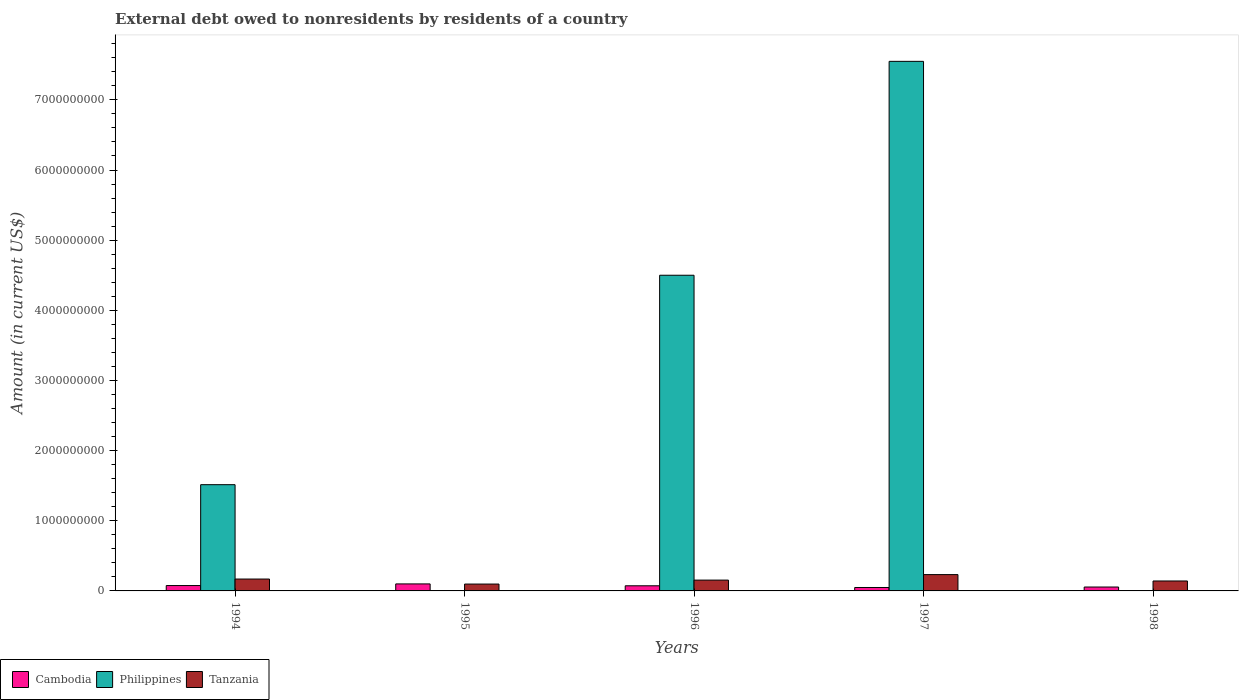How many groups of bars are there?
Provide a succinct answer. 5. Are the number of bars per tick equal to the number of legend labels?
Your answer should be very brief. No. How many bars are there on the 4th tick from the left?
Make the answer very short. 3. How many bars are there on the 1st tick from the right?
Give a very brief answer. 2. What is the external debt owed by residents in Tanzania in 1994?
Offer a very short reply. 1.69e+08. Across all years, what is the maximum external debt owed by residents in Philippines?
Your answer should be very brief. 7.55e+09. Across all years, what is the minimum external debt owed by residents in Cambodia?
Your response must be concise. 4.88e+07. In which year was the external debt owed by residents in Philippines maximum?
Provide a short and direct response. 1997. What is the total external debt owed by residents in Tanzania in the graph?
Ensure brevity in your answer.  7.96e+08. What is the difference between the external debt owed by residents in Tanzania in 1995 and that in 1998?
Offer a terse response. -4.38e+07. What is the difference between the external debt owed by residents in Tanzania in 1996 and the external debt owed by residents in Cambodia in 1995?
Your answer should be very brief. 5.44e+07. What is the average external debt owed by residents in Tanzania per year?
Your response must be concise. 1.59e+08. In the year 1997, what is the difference between the external debt owed by residents in Cambodia and external debt owed by residents in Philippines?
Give a very brief answer. -7.50e+09. What is the ratio of the external debt owed by residents in Cambodia in 1995 to that in 1996?
Offer a terse response. 1.37. Is the external debt owed by residents in Cambodia in 1997 less than that in 1998?
Your response must be concise. Yes. What is the difference between the highest and the second highest external debt owed by residents in Cambodia?
Your answer should be compact. 2.35e+07. What is the difference between the highest and the lowest external debt owed by residents in Philippines?
Provide a succinct answer. 7.55e+09. Is it the case that in every year, the sum of the external debt owed by residents in Cambodia and external debt owed by residents in Philippines is greater than the external debt owed by residents in Tanzania?
Your answer should be very brief. No. What is the difference between two consecutive major ticks on the Y-axis?
Make the answer very short. 1.00e+09. Does the graph contain grids?
Your answer should be very brief. No. Where does the legend appear in the graph?
Offer a terse response. Bottom left. How are the legend labels stacked?
Ensure brevity in your answer.  Horizontal. What is the title of the graph?
Offer a terse response. External debt owed to nonresidents by residents of a country. Does "China" appear as one of the legend labels in the graph?
Your answer should be compact. No. What is the label or title of the X-axis?
Provide a succinct answer. Years. What is the label or title of the Y-axis?
Make the answer very short. Amount (in current US$). What is the Amount (in current US$) in Cambodia in 1994?
Provide a succinct answer. 7.64e+07. What is the Amount (in current US$) of Philippines in 1994?
Offer a terse response. 1.51e+09. What is the Amount (in current US$) of Tanzania in 1994?
Offer a very short reply. 1.69e+08. What is the Amount (in current US$) in Cambodia in 1995?
Offer a very short reply. 1.00e+08. What is the Amount (in current US$) in Tanzania in 1995?
Give a very brief answer. 9.79e+07. What is the Amount (in current US$) in Cambodia in 1996?
Provide a succinct answer. 7.31e+07. What is the Amount (in current US$) of Philippines in 1996?
Your response must be concise. 4.50e+09. What is the Amount (in current US$) in Tanzania in 1996?
Your response must be concise. 1.54e+08. What is the Amount (in current US$) of Cambodia in 1997?
Your response must be concise. 4.88e+07. What is the Amount (in current US$) in Philippines in 1997?
Ensure brevity in your answer.  7.55e+09. What is the Amount (in current US$) of Tanzania in 1997?
Provide a succinct answer. 2.33e+08. What is the Amount (in current US$) in Cambodia in 1998?
Offer a terse response. 5.55e+07. What is the Amount (in current US$) of Tanzania in 1998?
Ensure brevity in your answer.  1.42e+08. Across all years, what is the maximum Amount (in current US$) of Cambodia?
Your answer should be compact. 1.00e+08. Across all years, what is the maximum Amount (in current US$) in Philippines?
Make the answer very short. 7.55e+09. Across all years, what is the maximum Amount (in current US$) of Tanzania?
Offer a very short reply. 2.33e+08. Across all years, what is the minimum Amount (in current US$) in Cambodia?
Give a very brief answer. 4.88e+07. Across all years, what is the minimum Amount (in current US$) in Philippines?
Provide a short and direct response. 0. Across all years, what is the minimum Amount (in current US$) of Tanzania?
Ensure brevity in your answer.  9.79e+07. What is the total Amount (in current US$) in Cambodia in the graph?
Provide a short and direct response. 3.54e+08. What is the total Amount (in current US$) in Philippines in the graph?
Your answer should be compact. 1.36e+1. What is the total Amount (in current US$) of Tanzania in the graph?
Keep it short and to the point. 7.96e+08. What is the difference between the Amount (in current US$) in Cambodia in 1994 and that in 1995?
Your answer should be very brief. -2.35e+07. What is the difference between the Amount (in current US$) in Tanzania in 1994 and that in 1995?
Your response must be concise. 7.14e+07. What is the difference between the Amount (in current US$) of Cambodia in 1994 and that in 1996?
Keep it short and to the point. 3.33e+06. What is the difference between the Amount (in current US$) in Philippines in 1994 and that in 1996?
Your answer should be very brief. -2.99e+09. What is the difference between the Amount (in current US$) of Tanzania in 1994 and that in 1996?
Keep it short and to the point. 1.50e+07. What is the difference between the Amount (in current US$) of Cambodia in 1994 and that in 1997?
Give a very brief answer. 2.76e+07. What is the difference between the Amount (in current US$) of Philippines in 1994 and that in 1997?
Provide a short and direct response. -6.03e+09. What is the difference between the Amount (in current US$) of Tanzania in 1994 and that in 1997?
Provide a short and direct response. -6.34e+07. What is the difference between the Amount (in current US$) of Cambodia in 1994 and that in 1998?
Provide a succinct answer. 2.09e+07. What is the difference between the Amount (in current US$) in Tanzania in 1994 and that in 1998?
Your response must be concise. 2.75e+07. What is the difference between the Amount (in current US$) of Cambodia in 1995 and that in 1996?
Make the answer very short. 2.69e+07. What is the difference between the Amount (in current US$) in Tanzania in 1995 and that in 1996?
Keep it short and to the point. -5.64e+07. What is the difference between the Amount (in current US$) in Cambodia in 1995 and that in 1997?
Provide a short and direct response. 5.12e+07. What is the difference between the Amount (in current US$) of Tanzania in 1995 and that in 1997?
Ensure brevity in your answer.  -1.35e+08. What is the difference between the Amount (in current US$) of Cambodia in 1995 and that in 1998?
Keep it short and to the point. 4.45e+07. What is the difference between the Amount (in current US$) of Tanzania in 1995 and that in 1998?
Your answer should be compact. -4.38e+07. What is the difference between the Amount (in current US$) in Cambodia in 1996 and that in 1997?
Make the answer very short. 2.43e+07. What is the difference between the Amount (in current US$) in Philippines in 1996 and that in 1997?
Make the answer very short. -3.05e+09. What is the difference between the Amount (in current US$) of Tanzania in 1996 and that in 1997?
Make the answer very short. -7.84e+07. What is the difference between the Amount (in current US$) in Cambodia in 1996 and that in 1998?
Give a very brief answer. 1.76e+07. What is the difference between the Amount (in current US$) of Tanzania in 1996 and that in 1998?
Your answer should be compact. 1.26e+07. What is the difference between the Amount (in current US$) in Cambodia in 1997 and that in 1998?
Keep it short and to the point. -6.68e+06. What is the difference between the Amount (in current US$) in Tanzania in 1997 and that in 1998?
Give a very brief answer. 9.10e+07. What is the difference between the Amount (in current US$) in Cambodia in 1994 and the Amount (in current US$) in Tanzania in 1995?
Offer a very short reply. -2.15e+07. What is the difference between the Amount (in current US$) of Philippines in 1994 and the Amount (in current US$) of Tanzania in 1995?
Offer a very short reply. 1.42e+09. What is the difference between the Amount (in current US$) of Cambodia in 1994 and the Amount (in current US$) of Philippines in 1996?
Give a very brief answer. -4.42e+09. What is the difference between the Amount (in current US$) in Cambodia in 1994 and the Amount (in current US$) in Tanzania in 1996?
Keep it short and to the point. -7.79e+07. What is the difference between the Amount (in current US$) in Philippines in 1994 and the Amount (in current US$) in Tanzania in 1996?
Provide a succinct answer. 1.36e+09. What is the difference between the Amount (in current US$) of Cambodia in 1994 and the Amount (in current US$) of Philippines in 1997?
Your answer should be compact. -7.47e+09. What is the difference between the Amount (in current US$) in Cambodia in 1994 and the Amount (in current US$) in Tanzania in 1997?
Your answer should be very brief. -1.56e+08. What is the difference between the Amount (in current US$) in Philippines in 1994 and the Amount (in current US$) in Tanzania in 1997?
Your response must be concise. 1.28e+09. What is the difference between the Amount (in current US$) of Cambodia in 1994 and the Amount (in current US$) of Tanzania in 1998?
Ensure brevity in your answer.  -6.53e+07. What is the difference between the Amount (in current US$) in Philippines in 1994 and the Amount (in current US$) in Tanzania in 1998?
Ensure brevity in your answer.  1.37e+09. What is the difference between the Amount (in current US$) in Cambodia in 1995 and the Amount (in current US$) in Philippines in 1996?
Your answer should be compact. -4.40e+09. What is the difference between the Amount (in current US$) of Cambodia in 1995 and the Amount (in current US$) of Tanzania in 1996?
Offer a very short reply. -5.44e+07. What is the difference between the Amount (in current US$) of Cambodia in 1995 and the Amount (in current US$) of Philippines in 1997?
Keep it short and to the point. -7.45e+09. What is the difference between the Amount (in current US$) in Cambodia in 1995 and the Amount (in current US$) in Tanzania in 1997?
Give a very brief answer. -1.33e+08. What is the difference between the Amount (in current US$) in Cambodia in 1995 and the Amount (in current US$) in Tanzania in 1998?
Ensure brevity in your answer.  -4.18e+07. What is the difference between the Amount (in current US$) of Cambodia in 1996 and the Amount (in current US$) of Philippines in 1997?
Your response must be concise. -7.48e+09. What is the difference between the Amount (in current US$) in Cambodia in 1996 and the Amount (in current US$) in Tanzania in 1997?
Your answer should be very brief. -1.60e+08. What is the difference between the Amount (in current US$) of Philippines in 1996 and the Amount (in current US$) of Tanzania in 1997?
Ensure brevity in your answer.  4.27e+09. What is the difference between the Amount (in current US$) of Cambodia in 1996 and the Amount (in current US$) of Tanzania in 1998?
Give a very brief answer. -6.87e+07. What is the difference between the Amount (in current US$) of Philippines in 1996 and the Amount (in current US$) of Tanzania in 1998?
Make the answer very short. 4.36e+09. What is the difference between the Amount (in current US$) of Cambodia in 1997 and the Amount (in current US$) of Tanzania in 1998?
Your answer should be compact. -9.30e+07. What is the difference between the Amount (in current US$) in Philippines in 1997 and the Amount (in current US$) in Tanzania in 1998?
Your answer should be very brief. 7.41e+09. What is the average Amount (in current US$) in Cambodia per year?
Keep it short and to the point. 7.08e+07. What is the average Amount (in current US$) in Philippines per year?
Make the answer very short. 2.71e+09. What is the average Amount (in current US$) of Tanzania per year?
Provide a short and direct response. 1.59e+08. In the year 1994, what is the difference between the Amount (in current US$) of Cambodia and Amount (in current US$) of Philippines?
Your answer should be compact. -1.44e+09. In the year 1994, what is the difference between the Amount (in current US$) of Cambodia and Amount (in current US$) of Tanzania?
Make the answer very short. -9.29e+07. In the year 1994, what is the difference between the Amount (in current US$) in Philippines and Amount (in current US$) in Tanzania?
Your answer should be compact. 1.35e+09. In the year 1995, what is the difference between the Amount (in current US$) in Cambodia and Amount (in current US$) in Tanzania?
Provide a short and direct response. 2.01e+06. In the year 1996, what is the difference between the Amount (in current US$) in Cambodia and Amount (in current US$) in Philippines?
Offer a terse response. -4.43e+09. In the year 1996, what is the difference between the Amount (in current US$) of Cambodia and Amount (in current US$) of Tanzania?
Your answer should be very brief. -8.12e+07. In the year 1996, what is the difference between the Amount (in current US$) in Philippines and Amount (in current US$) in Tanzania?
Make the answer very short. 4.35e+09. In the year 1997, what is the difference between the Amount (in current US$) of Cambodia and Amount (in current US$) of Philippines?
Your answer should be compact. -7.50e+09. In the year 1997, what is the difference between the Amount (in current US$) of Cambodia and Amount (in current US$) of Tanzania?
Keep it short and to the point. -1.84e+08. In the year 1997, what is the difference between the Amount (in current US$) of Philippines and Amount (in current US$) of Tanzania?
Offer a very short reply. 7.32e+09. In the year 1998, what is the difference between the Amount (in current US$) of Cambodia and Amount (in current US$) of Tanzania?
Provide a succinct answer. -8.63e+07. What is the ratio of the Amount (in current US$) in Cambodia in 1994 to that in 1995?
Your answer should be very brief. 0.76. What is the ratio of the Amount (in current US$) in Tanzania in 1994 to that in 1995?
Your response must be concise. 1.73. What is the ratio of the Amount (in current US$) in Cambodia in 1994 to that in 1996?
Your response must be concise. 1.05. What is the ratio of the Amount (in current US$) of Philippines in 1994 to that in 1996?
Your answer should be very brief. 0.34. What is the ratio of the Amount (in current US$) of Tanzania in 1994 to that in 1996?
Provide a short and direct response. 1.1. What is the ratio of the Amount (in current US$) of Cambodia in 1994 to that in 1997?
Your response must be concise. 1.57. What is the ratio of the Amount (in current US$) in Philippines in 1994 to that in 1997?
Provide a short and direct response. 0.2. What is the ratio of the Amount (in current US$) of Tanzania in 1994 to that in 1997?
Offer a terse response. 0.73. What is the ratio of the Amount (in current US$) of Cambodia in 1994 to that in 1998?
Give a very brief answer. 1.38. What is the ratio of the Amount (in current US$) of Tanzania in 1994 to that in 1998?
Give a very brief answer. 1.19. What is the ratio of the Amount (in current US$) in Cambodia in 1995 to that in 1996?
Your answer should be compact. 1.37. What is the ratio of the Amount (in current US$) in Tanzania in 1995 to that in 1996?
Give a very brief answer. 0.63. What is the ratio of the Amount (in current US$) of Cambodia in 1995 to that in 1997?
Give a very brief answer. 2.05. What is the ratio of the Amount (in current US$) in Tanzania in 1995 to that in 1997?
Your response must be concise. 0.42. What is the ratio of the Amount (in current US$) in Cambodia in 1995 to that in 1998?
Your answer should be compact. 1.8. What is the ratio of the Amount (in current US$) of Tanzania in 1995 to that in 1998?
Your answer should be very brief. 0.69. What is the ratio of the Amount (in current US$) in Cambodia in 1996 to that in 1997?
Ensure brevity in your answer.  1.5. What is the ratio of the Amount (in current US$) in Philippines in 1996 to that in 1997?
Ensure brevity in your answer.  0.6. What is the ratio of the Amount (in current US$) in Tanzania in 1996 to that in 1997?
Make the answer very short. 0.66. What is the ratio of the Amount (in current US$) in Cambodia in 1996 to that in 1998?
Offer a very short reply. 1.32. What is the ratio of the Amount (in current US$) in Tanzania in 1996 to that in 1998?
Your answer should be very brief. 1.09. What is the ratio of the Amount (in current US$) of Cambodia in 1997 to that in 1998?
Provide a short and direct response. 0.88. What is the ratio of the Amount (in current US$) in Tanzania in 1997 to that in 1998?
Give a very brief answer. 1.64. What is the difference between the highest and the second highest Amount (in current US$) of Cambodia?
Your answer should be very brief. 2.35e+07. What is the difference between the highest and the second highest Amount (in current US$) in Philippines?
Provide a short and direct response. 3.05e+09. What is the difference between the highest and the second highest Amount (in current US$) of Tanzania?
Keep it short and to the point. 6.34e+07. What is the difference between the highest and the lowest Amount (in current US$) of Cambodia?
Ensure brevity in your answer.  5.12e+07. What is the difference between the highest and the lowest Amount (in current US$) in Philippines?
Provide a succinct answer. 7.55e+09. What is the difference between the highest and the lowest Amount (in current US$) of Tanzania?
Ensure brevity in your answer.  1.35e+08. 